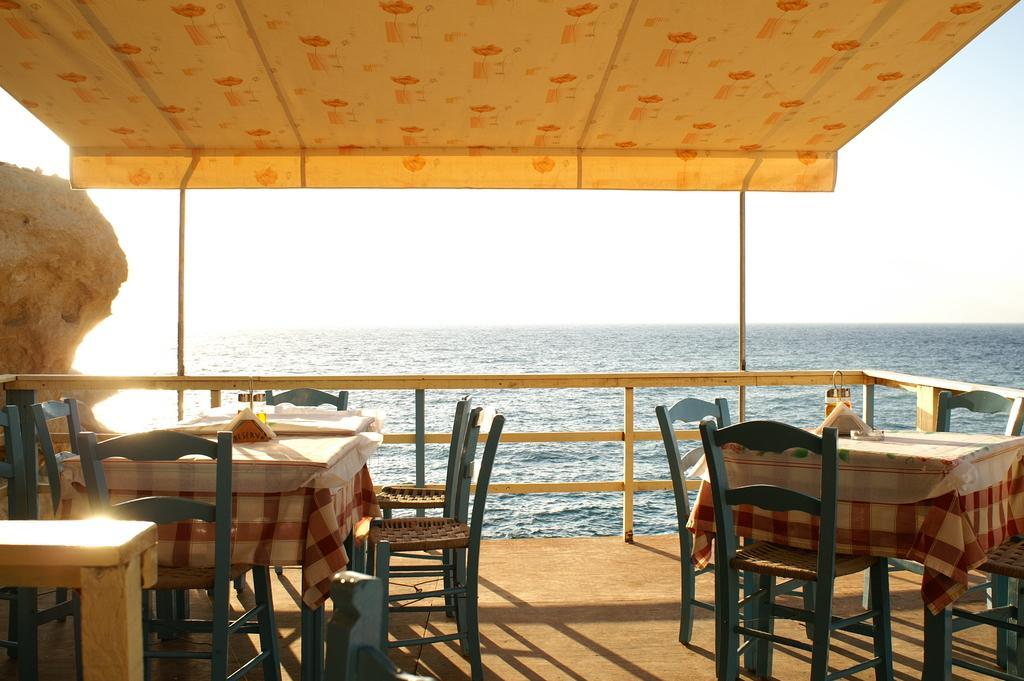How would you summarize this image in a sentence or two? In the foreground I can see tables, chairs, fence, some objects on it and a boat in the water. In the background I can see an ocean and the sky. This image is taken may be in the ocean. 